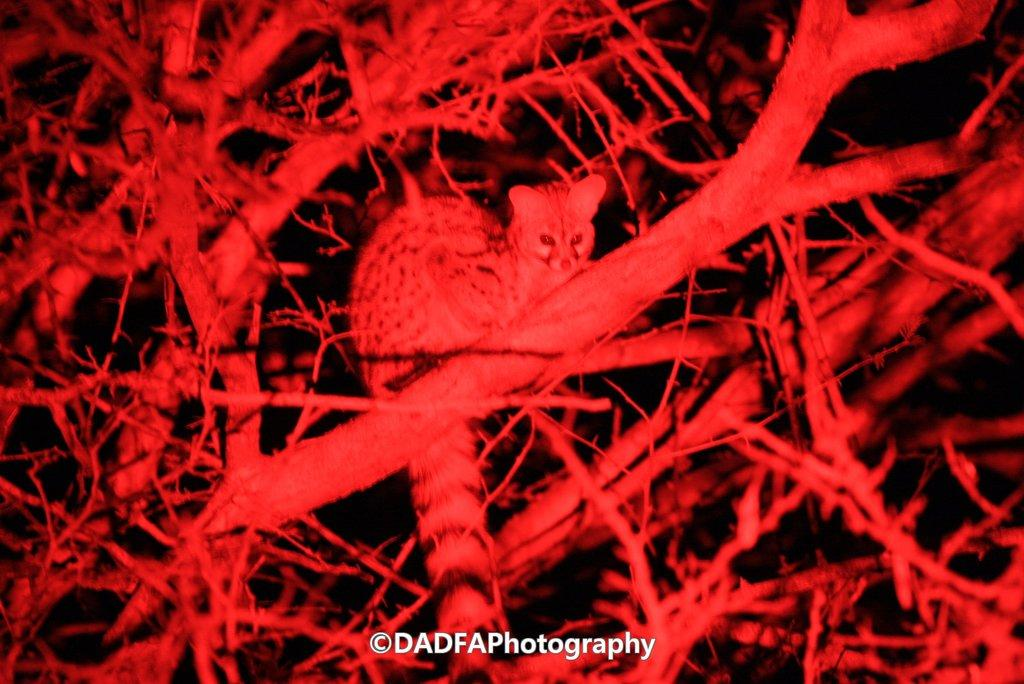What type of image is being shown? The image is a microscopic picture. What type of harmony can be observed between the goldfish in the image? There are no goldfish present in the image, as it is a microscopic picture. 